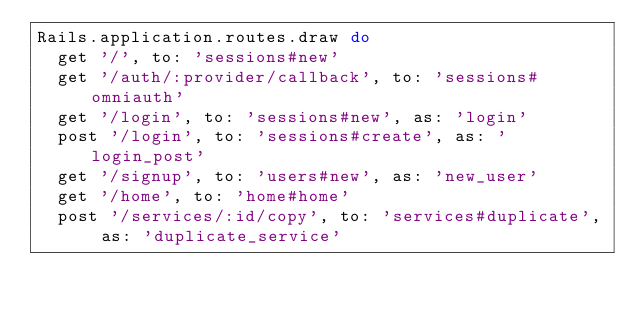<code> <loc_0><loc_0><loc_500><loc_500><_Ruby_>Rails.application.routes.draw do
  get '/', to: 'sessions#new'
  get '/auth/:provider/callback', to: 'sessions#omniauth'
  get '/login', to: 'sessions#new', as: 'login'
  post '/login', to: 'sessions#create', as: 'login_post'
  get '/signup', to: 'users#new', as: 'new_user'
  get '/home', to: 'home#home'  
  post '/services/:id/copy', to: 'services#duplicate', as: 'duplicate_service'</code> 